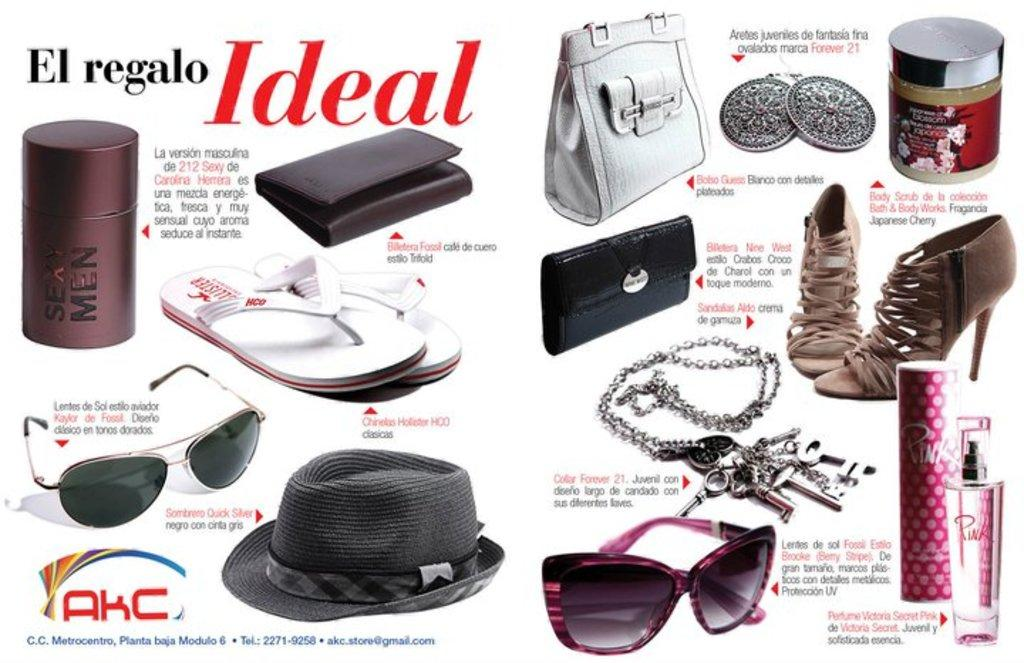What type of visual is the image? The image is a poster. What can be found on the poster besides visual elements? There is text written on the poster. What type of products are featured in the image? There are perfume bottles, a purse, and footwear items in the image. What additional accessory is present in the image? There are goggles in the image. What type of footwear is shown in the image? There are sandals in the image. What other item can be seen in the image? There is a chain with keys in the image. What grade does the representative receive for their performance in the image? There is no representative present in the image, and therefore no performance to evaluate or grade. 